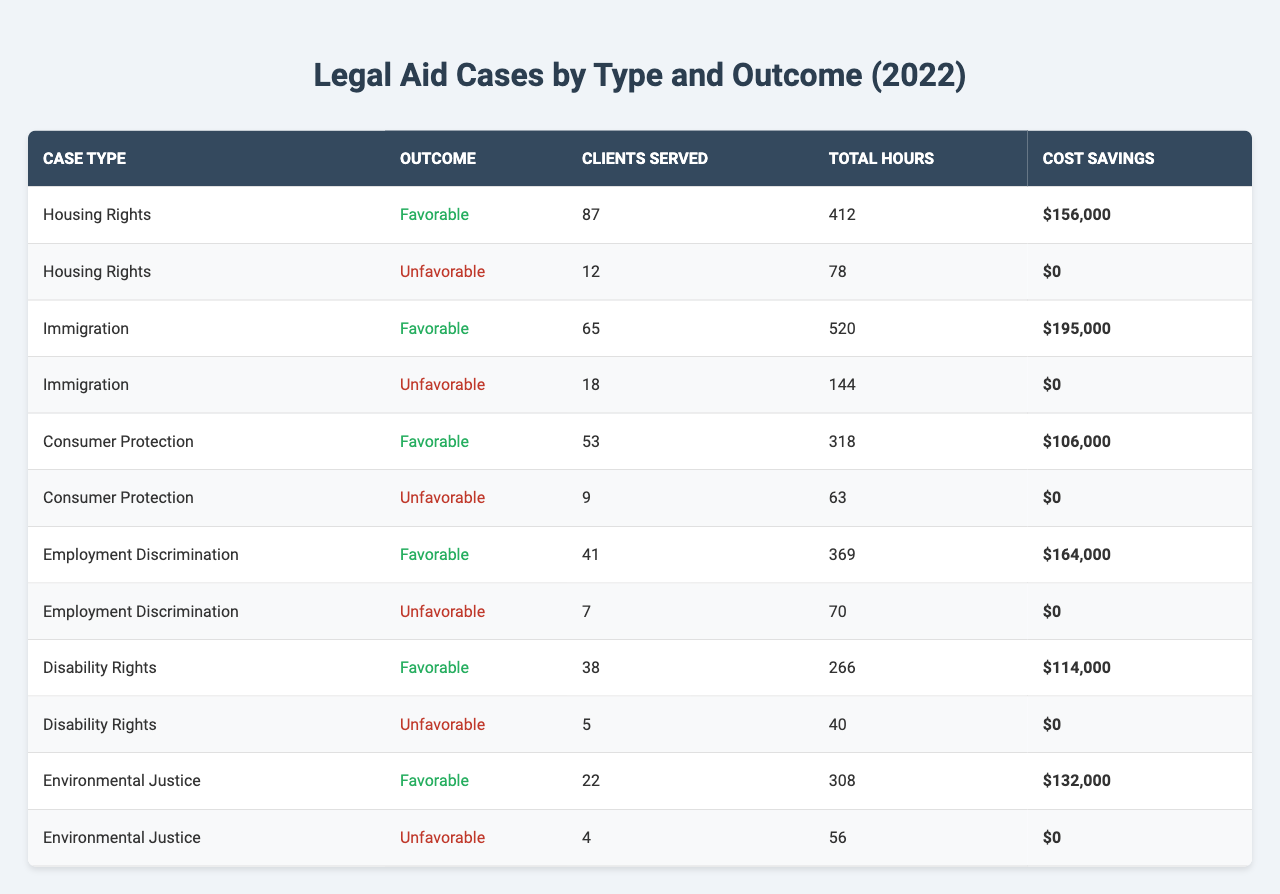What is the total cost savings from all favorable outcomes? To find the total cost savings from favorable outcomes, we need to sum the cost savings for each case type where the outcome is "Favorable." These amounts are: $156,000 (Housing Rights) + $195,000 (Immigration) + $106,000 (Consumer Protection) + $164,000 (Employment Discrimination) + $114,000 (Disability Rights) + $132,000 (Environmental Justice). Adding these values yields $156,000 + 195,000 + 106,000 + 164,000 + 114,000 + 132,000 = $867,000.
Answer: $867,000 How many clients were served in total across all case types? To get the total number of clients served, we add the "Clients Served" for each case type. The numbers are: 87 (Housing Rights) + 12 + 65 (Immigration) + 18 + 53 (Consumer Protection) + 9 + 41 (Employment Discrimination) + 7 + 38 (Disability Rights) + 5 + 22 (Environmental Justice) + 4. Summing these gives: 87 + 12 + 65 + 18 + 53 + 9 + 41 + 7 + 38 + 5 + 22 + 4 = 361.
Answer: 361 Were there any "Unfavorable" outcomes with cost savings? There are no "Unfavorable" outcomes that resulted in cost savings, as all entries with "Unfavorable" have a cost savings of $0.
Answer: No What case type had the least number of clients served? Looking through the "Clients Served" column, “Environmental Justice (Unfavorable)” has the least clients served with just 4.
Answer: Environmental Justice (Unfavorable) How much time was spent on "Consumer Protection" cases in total? To find the total hours spent on "Consumer Protection" cases, we add the total hours for both outcomes. The total hours are: 318 (Favorable) + 63 (Unfavorable) = 381 hours.
Answer: 381 hours How many more clients were served in "Favorable" outcomes compared to "Unfavorable" outcomes across all cases? We first find the total clients served in favorable outcomes: 87 + 65 + 53 + 41 + 38 + 22 = 306. Next, for unfavorable outcomes: 12 + 18 + 9 + 7 + 5 + 4 = 55. The difference is 306 - 55 = 251.
Answer: 251 Which case type had the highest number of total hours billed? By examining the "Total Hours" column, "Immigration (Favorable)" has the highest total hours at 520.
Answer: Immigration (Favorable) What percentage of the total clients served had favorable outcomes? Total clients served are 361 (calculated earlier). The clients served with favorable outcomes are 306. To find the percentage: (306/361) * 100 = approximately 84.8%.
Answer: 84.8% How many types of cases resulted in a favorable outcome? Reviewing the table, six types of cases had favorable outcomes: Housing Rights, Immigration, Consumer Protection, Employment Discrimination, Disability Rights, and Environmental Justice. Thus, there are 6 types.
Answer: 6 What is the ratio of favorable to unfavorable outcomes for "Housing Rights"? For "Housing Rights," there are 87 favorable and 12 unfavorable. The ratio is 87:12, which can be simplified to 7.25:1.
Answer: 7.25:1 